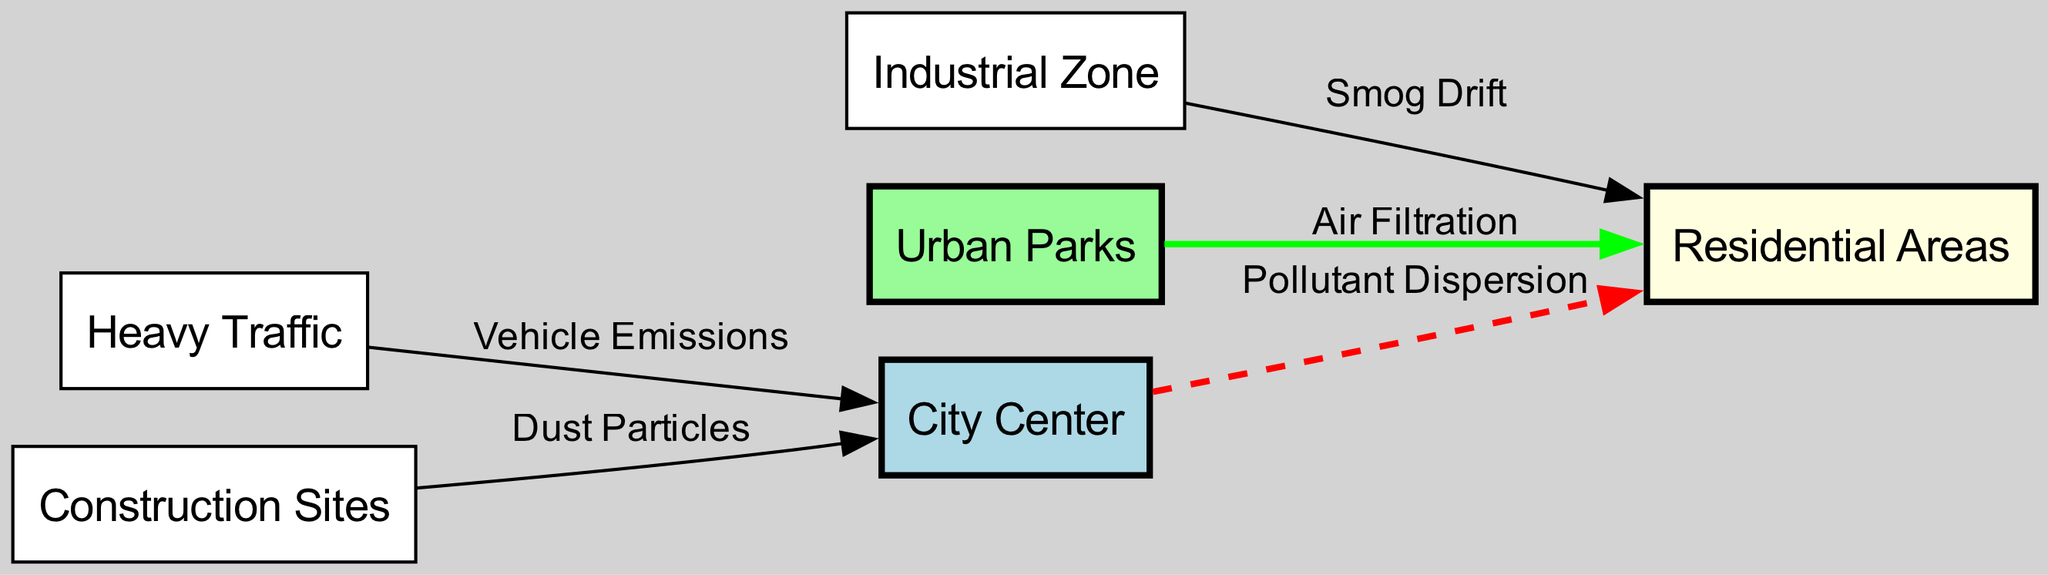what is the total number of nodes in the diagram? The diagram includes six nodes: City Center, Heavy Traffic, Construction Sites, Industrial Zone, Urban Parks, and Residential Areas. Therefore, the total count of nodes is six.
Answer: 6 which node is connected to the City Center by Vehicle Emissions? The edge labeled "Vehicle Emissions" directly connects Heavy Traffic to the City Center, indicating that this particular node is responsible for the emissions reaching the City Center.
Answer: Heavy Traffic what type of particles does the Construction Sites node contribute? The relationship labeled "Dust Particles" indicates that Construction Sites are contributing dust particles to the City Center, which follows the connection shown in the diagram.
Answer: Dust Particles how does air pollution from the Industrial Zone affect Residential Areas? The edge labeled "Smog Drift" shows that pollution from the Industrial Zone drifts and impacts the Residential Areas, demonstrating a negative effect. Therefore, the relationship describes how smog from the industry affects the nearby neighborhoods.
Answer: Smog Drift which node contributes air filtration to Residential Areas? The connection labeled "Air Filtration" indicates that Urban Parks help filter the air that reaches the Residential Areas, thus improving air quality in that direction.
Answer: Urban Parks 